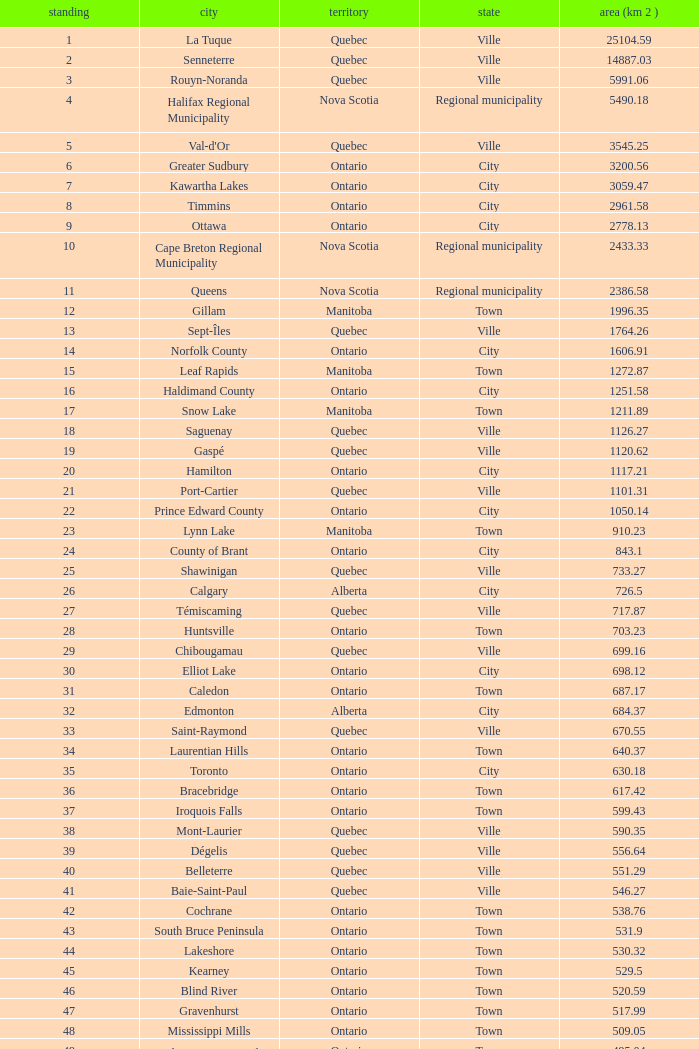What is the highest Area (KM 2) for the Province of Ontario, that has the Status of Town, a Municipality of Minto, and a Rank that's smaller than 84? None. Write the full table. {'header': ['standing', 'city', 'territory', 'state', 'area (km 2 )'], 'rows': [['1', 'La Tuque', 'Quebec', 'Ville', '25104.59'], ['2', 'Senneterre', 'Quebec', 'Ville', '14887.03'], ['3', 'Rouyn-Noranda', 'Quebec', 'Ville', '5991.06'], ['4', 'Halifax Regional Municipality', 'Nova Scotia', 'Regional municipality', '5490.18'], ['5', "Val-d'Or", 'Quebec', 'Ville', '3545.25'], ['6', 'Greater Sudbury', 'Ontario', 'City', '3200.56'], ['7', 'Kawartha Lakes', 'Ontario', 'City', '3059.47'], ['8', 'Timmins', 'Ontario', 'City', '2961.58'], ['9', 'Ottawa', 'Ontario', 'City', '2778.13'], ['10', 'Cape Breton Regional Municipality', 'Nova Scotia', 'Regional municipality', '2433.33'], ['11', 'Queens', 'Nova Scotia', 'Regional municipality', '2386.58'], ['12', 'Gillam', 'Manitoba', 'Town', '1996.35'], ['13', 'Sept-Îles', 'Quebec', 'Ville', '1764.26'], ['14', 'Norfolk County', 'Ontario', 'City', '1606.91'], ['15', 'Leaf Rapids', 'Manitoba', 'Town', '1272.87'], ['16', 'Haldimand County', 'Ontario', 'City', '1251.58'], ['17', 'Snow Lake', 'Manitoba', 'Town', '1211.89'], ['18', 'Saguenay', 'Quebec', 'Ville', '1126.27'], ['19', 'Gaspé', 'Quebec', 'Ville', '1120.62'], ['20', 'Hamilton', 'Ontario', 'City', '1117.21'], ['21', 'Port-Cartier', 'Quebec', 'Ville', '1101.31'], ['22', 'Prince Edward County', 'Ontario', 'City', '1050.14'], ['23', 'Lynn Lake', 'Manitoba', 'Town', '910.23'], ['24', 'County of Brant', 'Ontario', 'City', '843.1'], ['25', 'Shawinigan', 'Quebec', 'Ville', '733.27'], ['26', 'Calgary', 'Alberta', 'City', '726.5'], ['27', 'Témiscaming', 'Quebec', 'Ville', '717.87'], ['28', 'Huntsville', 'Ontario', 'Town', '703.23'], ['29', 'Chibougamau', 'Quebec', 'Ville', '699.16'], ['30', 'Elliot Lake', 'Ontario', 'City', '698.12'], ['31', 'Caledon', 'Ontario', 'Town', '687.17'], ['32', 'Edmonton', 'Alberta', 'City', '684.37'], ['33', 'Saint-Raymond', 'Quebec', 'Ville', '670.55'], ['34', 'Laurentian Hills', 'Ontario', 'Town', '640.37'], ['35', 'Toronto', 'Ontario', 'City', '630.18'], ['36', 'Bracebridge', 'Ontario', 'Town', '617.42'], ['37', 'Iroquois Falls', 'Ontario', 'Town', '599.43'], ['38', 'Mont-Laurier', 'Quebec', 'Ville', '590.35'], ['39', 'Dégelis', 'Quebec', 'Ville', '556.64'], ['40', 'Belleterre', 'Quebec', 'Ville', '551.29'], ['41', 'Baie-Saint-Paul', 'Quebec', 'Ville', '546.27'], ['42', 'Cochrane', 'Ontario', 'Town', '538.76'], ['43', 'South Bruce Peninsula', 'Ontario', 'Town', '531.9'], ['44', 'Lakeshore', 'Ontario', 'Town', '530.32'], ['45', 'Kearney', 'Ontario', 'Town', '529.5'], ['46', 'Blind River', 'Ontario', 'Town', '520.59'], ['47', 'Gravenhurst', 'Ontario', 'Town', '517.99'], ['48', 'Mississippi Mills', 'Ontario', 'Town', '509.05'], ['49', 'Northeastern Manitoulin and the Islands', 'Ontario', 'Town', '495.04'], ['50', 'Quinte West', 'Ontario', 'City', '493.85'], ['51', 'Mirabel', 'Quebec', 'Ville', '485.51'], ['52', 'Fermont', 'Quebec', 'Ville', '470.67'], ['53', 'Winnipeg', 'Manitoba', 'City', '464.01'], ['54', 'Greater Napanee', 'Ontario', 'Town', '459.71'], ['55', 'La Malbaie', 'Quebec', 'Ville', '459.34'], ['56', 'Rivière-Rouge', 'Quebec', 'Ville', '454.99'], ['57', 'Québec City', 'Quebec', 'Ville', '454.26'], ['58', 'Kingston', 'Ontario', 'City', '450.39'], ['59', 'Lévis', 'Quebec', 'Ville', '449.32'], ['60', "St. John's", 'Newfoundland and Labrador', 'City', '446.04'], ['61', 'Bécancour', 'Quebec', 'Ville', '441'], ['62', 'Percé', 'Quebec', 'Ville', '432.39'], ['63', 'Amos', 'Quebec', 'Ville', '430.06'], ['64', 'London', 'Ontario', 'City', '420.57'], ['65', 'Chandler', 'Quebec', 'Ville', '419.5'], ['66', 'Whitehorse', 'Yukon', 'City', '416.43'], ['67', 'Gracefield', 'Quebec', 'Ville', '386.21'], ['68', 'Baie Verte', 'Newfoundland and Labrador', 'Town', '371.07'], ['69', 'Milton', 'Ontario', 'Town', '366.61'], ['70', 'Montreal', 'Quebec', 'Ville', '365.13'], ['71', 'Saint-Félicien', 'Quebec', 'Ville', '363.57'], ['72', 'Abbotsford', 'British Columbia', 'City', '359.36'], ['73', 'Sherbrooke', 'Quebec', 'Ville', '353.46'], ['74', 'Gatineau', 'Quebec', 'Ville', '342.32'], ['75', 'Pohénégamook', 'Quebec', 'Ville', '340.33'], ['76', 'Baie-Comeau', 'Quebec', 'Ville', '338.88'], ['77', 'Thunder Bay', 'Ontario', 'City', '328.48'], ['78', 'Plympton–Wyoming', 'Ontario', 'Town', '318.76'], ['79', 'Surrey', 'British Columbia', 'City', '317.19'], ['80', 'Prince George', 'British Columbia', 'City', '316'], ['81', 'Saint John', 'New Brunswick', 'City', '315.49'], ['82', 'North Bay', 'Ontario', 'City', '314.91'], ['83', 'Happy Valley-Goose Bay', 'Newfoundland and Labrador', 'Town', '305.85'], ['84', 'Minto', 'Ontario', 'Town', '300.37'], ['85', 'Kamloops', 'British Columbia', 'City', '297.3'], ['86', 'Erin', 'Ontario', 'Town', '296.98'], ['87', 'Clarence-Rockland', 'Ontario', 'City', '296.53'], ['88', 'Cookshire-Eaton', 'Quebec', 'Ville', '295.93'], ['89', 'Dolbeau-Mistassini', 'Quebec', 'Ville', '295.67'], ['90', 'Trois-Rivières', 'Quebec', 'Ville', '288.92'], ['91', 'Mississauga', 'Ontario', 'City', '288.53'], ['92', 'Georgina', 'Ontario', 'Town', '287.72'], ['93', 'The Blue Mountains', 'Ontario', 'Town', '286.78'], ['94', 'Innisfil', 'Ontario', 'Town', '284.18'], ['95', 'Essex', 'Ontario', 'Town', '277.95'], ['96', 'Mono', 'Ontario', 'Town', '277.67'], ['97', 'Halton Hills', 'Ontario', 'Town', '276.26'], ['98', 'New Tecumseth', 'Ontario', 'Town', '274.18'], ['99', 'Vaughan', 'Ontario', 'City', '273.58'], ['100', 'Brampton', 'Ontario', 'City', '266.71']]} 